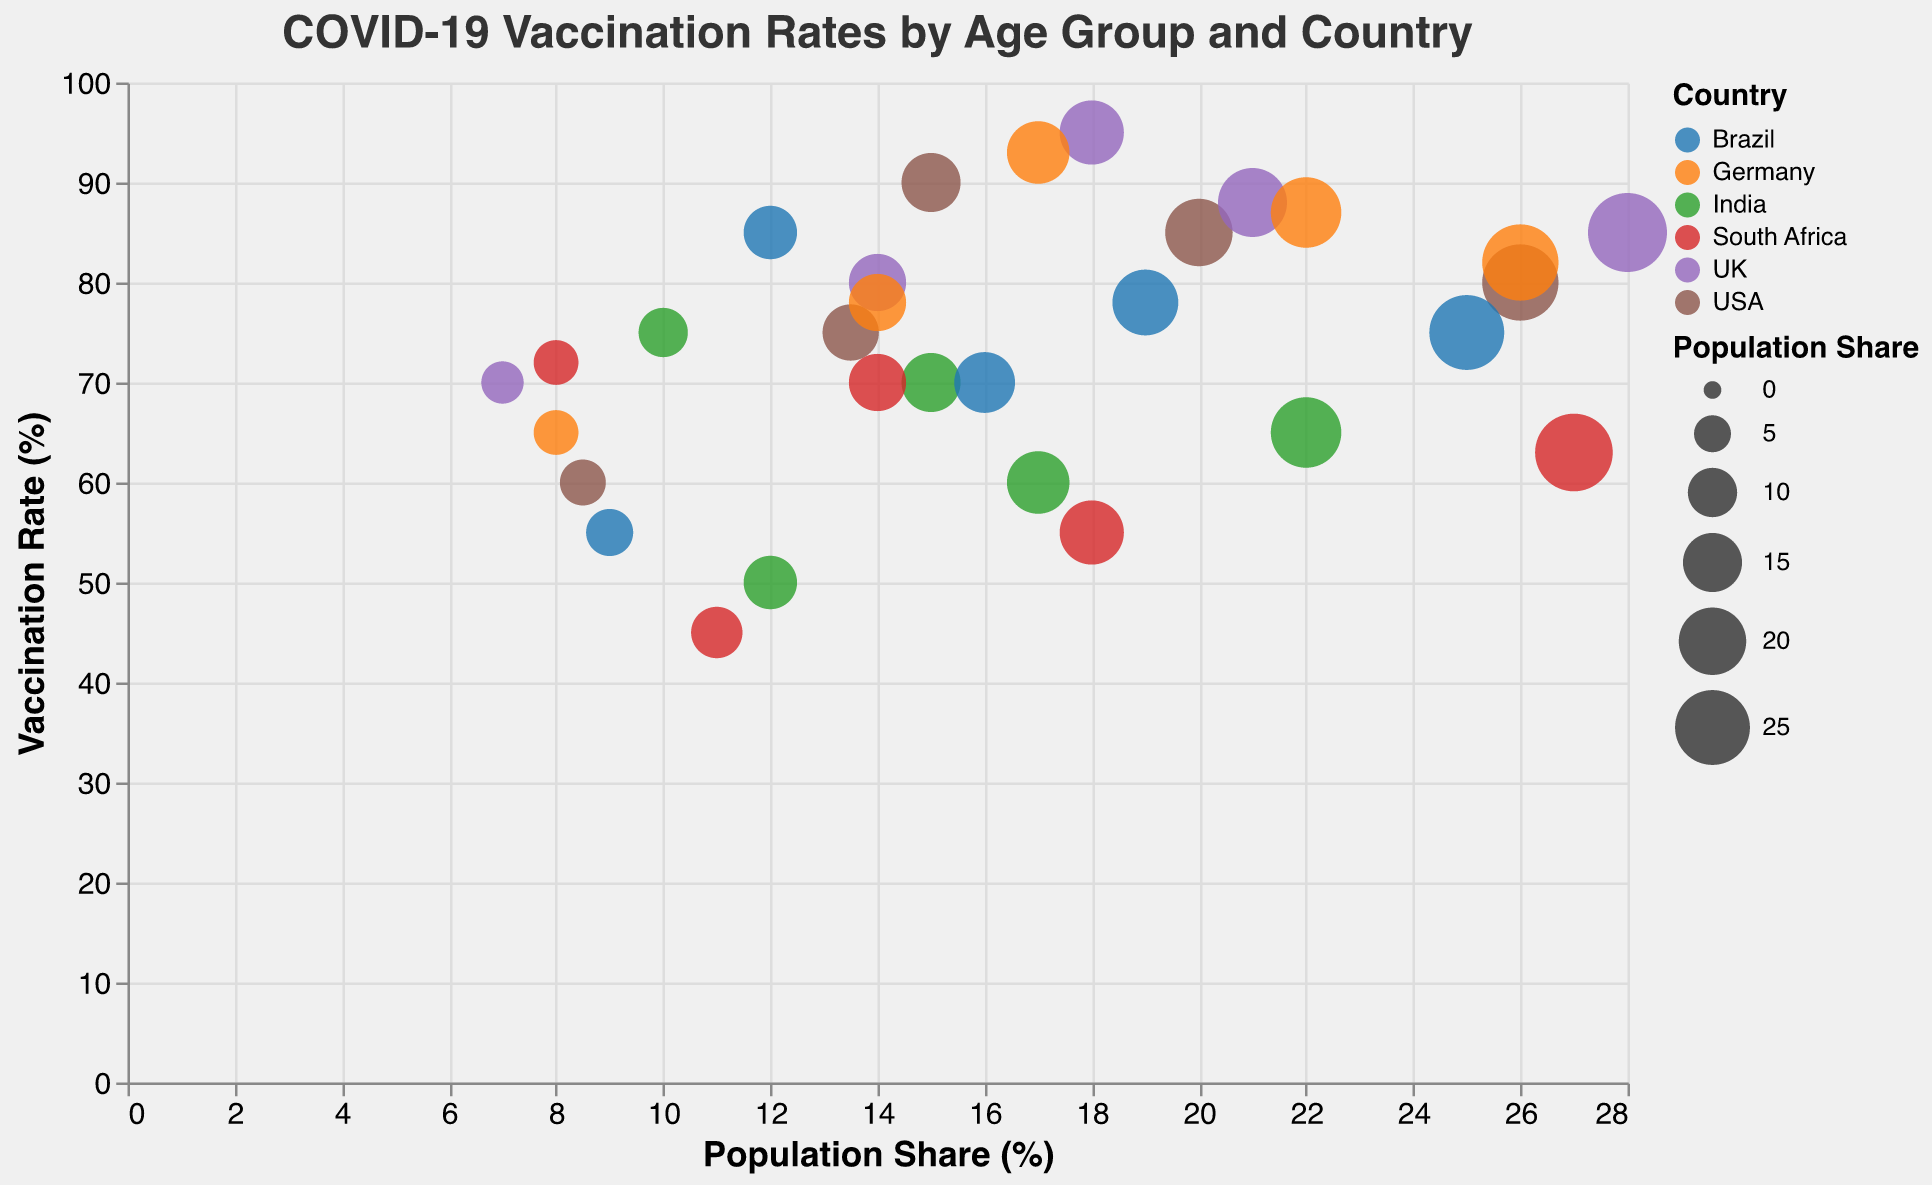How many countries are represented in the figure? The figure uses different colors to represent countries, and there are six distinct color segments in the legend, corresponding to the six countries represented.
Answer: 6 Which country has the highest vaccination rate for the age group 65+? By checking the y-axis value that corresponds to the age group 65+ for each country, the highest bubble is attributed to the UK with a vaccination rate of 95%.
Answer: UK Compare the vaccination rates for the age group 12-17 between the USA and South Africa. Which country shows higher vaccination rates? The y-axis values for the 12-17 age group for the USA and South Africa are 60% and 45% respectively. Thus, the USA has a higher vaccination rate.
Answer: USA What is the average vaccination rate for the age group 18-29 across all countries? The vaccination rates for the age group 18-29 are 75 (USA), 80 (UK), 60 (India), 70 (Brazil), 78 (Germany), and 55 (South Africa). Summing these gives 418, and dividing by 6 (the number of countries) gives an average of approximately 69.67%.
Answer: 69.67% Which age group in India has the lowest vaccination rate and what is the rate? By looking at the y-axis values for all age groups in India, the lowest percentage is 50% for the age group 12-17.
Answer: 12-17 Among the age groups in Germany, which one shows the largest population share and its corresponding vaccination rate? The largest population share in Germany is for age group 30-49 with 26%, and its corresponding vaccination rate is 82%.
Answer: 30-49, 82% What is the difference in vaccination rates between the age groups 30-49 and 50-64 in Brazil? Checking the y-axis for the age groups 30-49 and 50-64 in Brazil, the vaccination rates are 75% and 78%. The difference is 78 - 75 = 3%.
Answer: 3% For the UK, which age group has the smallest bubble (indicating the smallest population share) and what is the vaccination rate for this group? In the UK, the age group 12-17 has the smallest bubble, which corresponds to a population share of 7%, and the vaccination rate for this group is 70%.
Answer: 12-17, 70% 